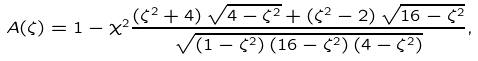Convert formula to latex. <formula><loc_0><loc_0><loc_500><loc_500>A ( \zeta ) = 1 - \chi ^ { 2 } \frac { \left ( \zeta ^ { 2 } + 4 \right ) \sqrt { 4 - \zeta ^ { 2 } } + \left ( \zeta ^ { 2 } - 2 \right ) \sqrt { 1 6 - \zeta ^ { 2 } } } { \sqrt { \left ( 1 - \zeta ^ { 2 } \right ) \left ( 1 6 - \zeta ^ { 2 } \right ) \left ( 4 - \zeta ^ { 2 } \right ) } } ,</formula> 